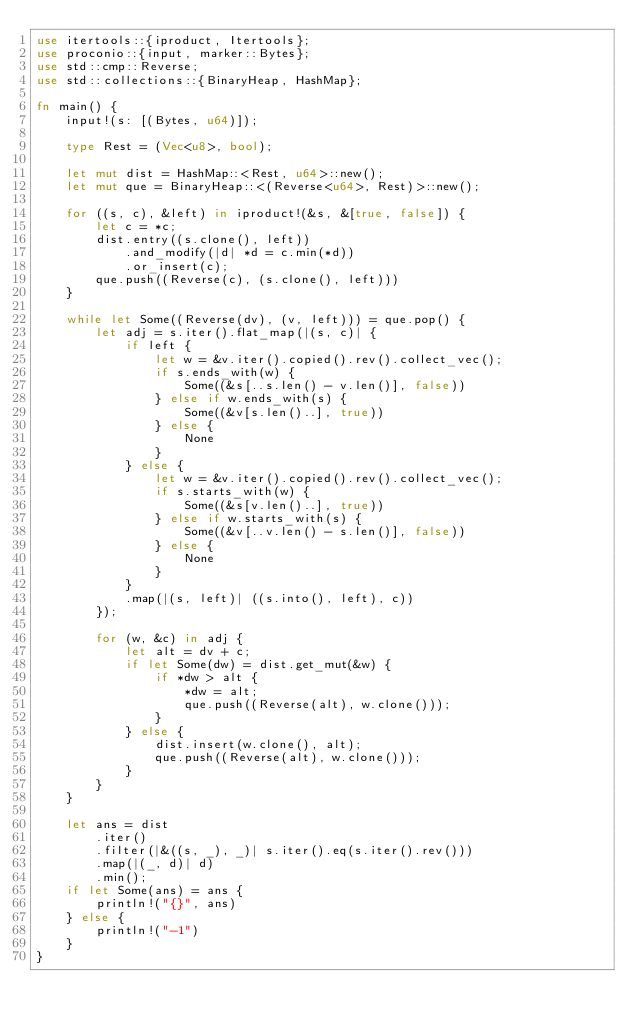Convert code to text. <code><loc_0><loc_0><loc_500><loc_500><_Rust_>use itertools::{iproduct, Itertools};
use proconio::{input, marker::Bytes};
use std::cmp::Reverse;
use std::collections::{BinaryHeap, HashMap};

fn main() {
    input!(s: [(Bytes, u64)]);

    type Rest = (Vec<u8>, bool);

    let mut dist = HashMap::<Rest, u64>::new();
    let mut que = BinaryHeap::<(Reverse<u64>, Rest)>::new();

    for ((s, c), &left) in iproduct!(&s, &[true, false]) {
        let c = *c;
        dist.entry((s.clone(), left))
            .and_modify(|d| *d = c.min(*d))
            .or_insert(c);
        que.push((Reverse(c), (s.clone(), left)))
    }

    while let Some((Reverse(dv), (v, left))) = que.pop() {
        let adj = s.iter().flat_map(|(s, c)| {
            if left {
                let w = &v.iter().copied().rev().collect_vec();
                if s.ends_with(w) {
                    Some((&s[..s.len() - v.len()], false))
                } else if w.ends_with(s) {
                    Some((&v[s.len()..], true))
                } else {
                    None
                }
            } else {
                let w = &v.iter().copied().rev().collect_vec();
                if s.starts_with(w) {
                    Some((&s[v.len()..], true))
                } else if w.starts_with(s) {
                    Some((&v[..v.len() - s.len()], false))
                } else {
                    None
                }
            }
            .map(|(s, left)| ((s.into(), left), c))
        });

        for (w, &c) in adj {
            let alt = dv + c;
            if let Some(dw) = dist.get_mut(&w) {
                if *dw > alt {
                    *dw = alt;
                    que.push((Reverse(alt), w.clone()));
                }
            } else {
                dist.insert(w.clone(), alt);
                que.push((Reverse(alt), w.clone()));
            }
        }
    }

    let ans = dist
        .iter()
        .filter(|&((s, _), _)| s.iter().eq(s.iter().rev()))
        .map(|(_, d)| d)
        .min();
    if let Some(ans) = ans {
        println!("{}", ans)
    } else {
        println!("-1")
    }
}
</code> 